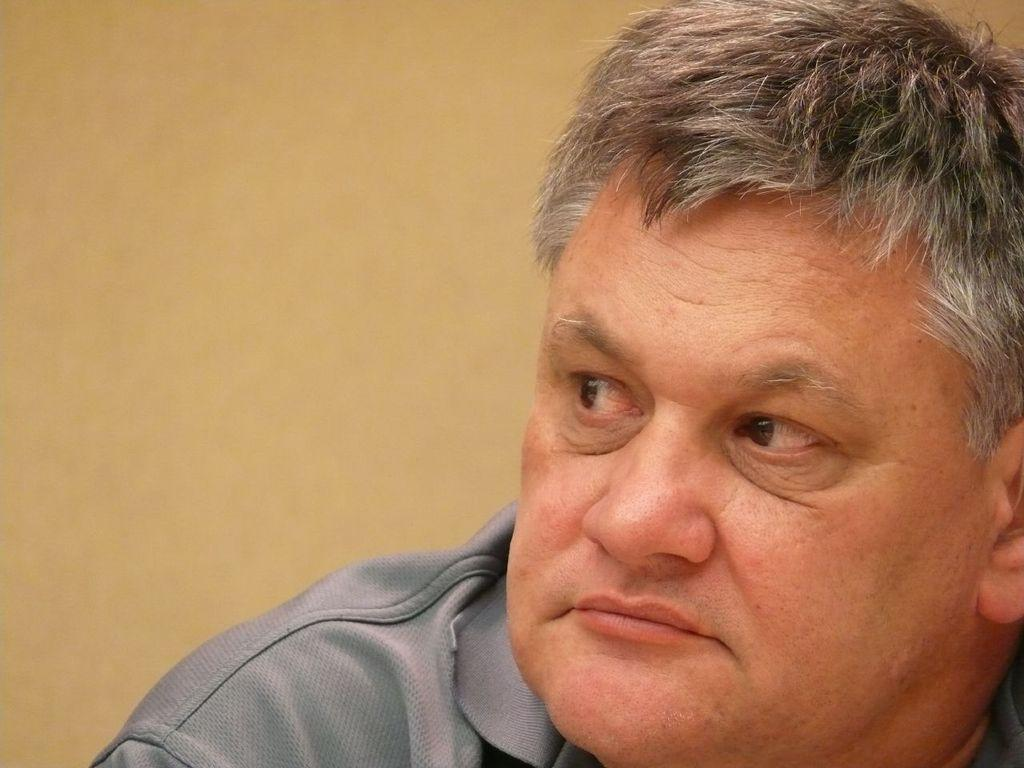What is present in the image? There is a person in the image. What is the person wearing? The person is wearing a grey t-shirt. What type of wool is the person using to make a statement in the image? There is no wool or statement-making activity present in the image. 